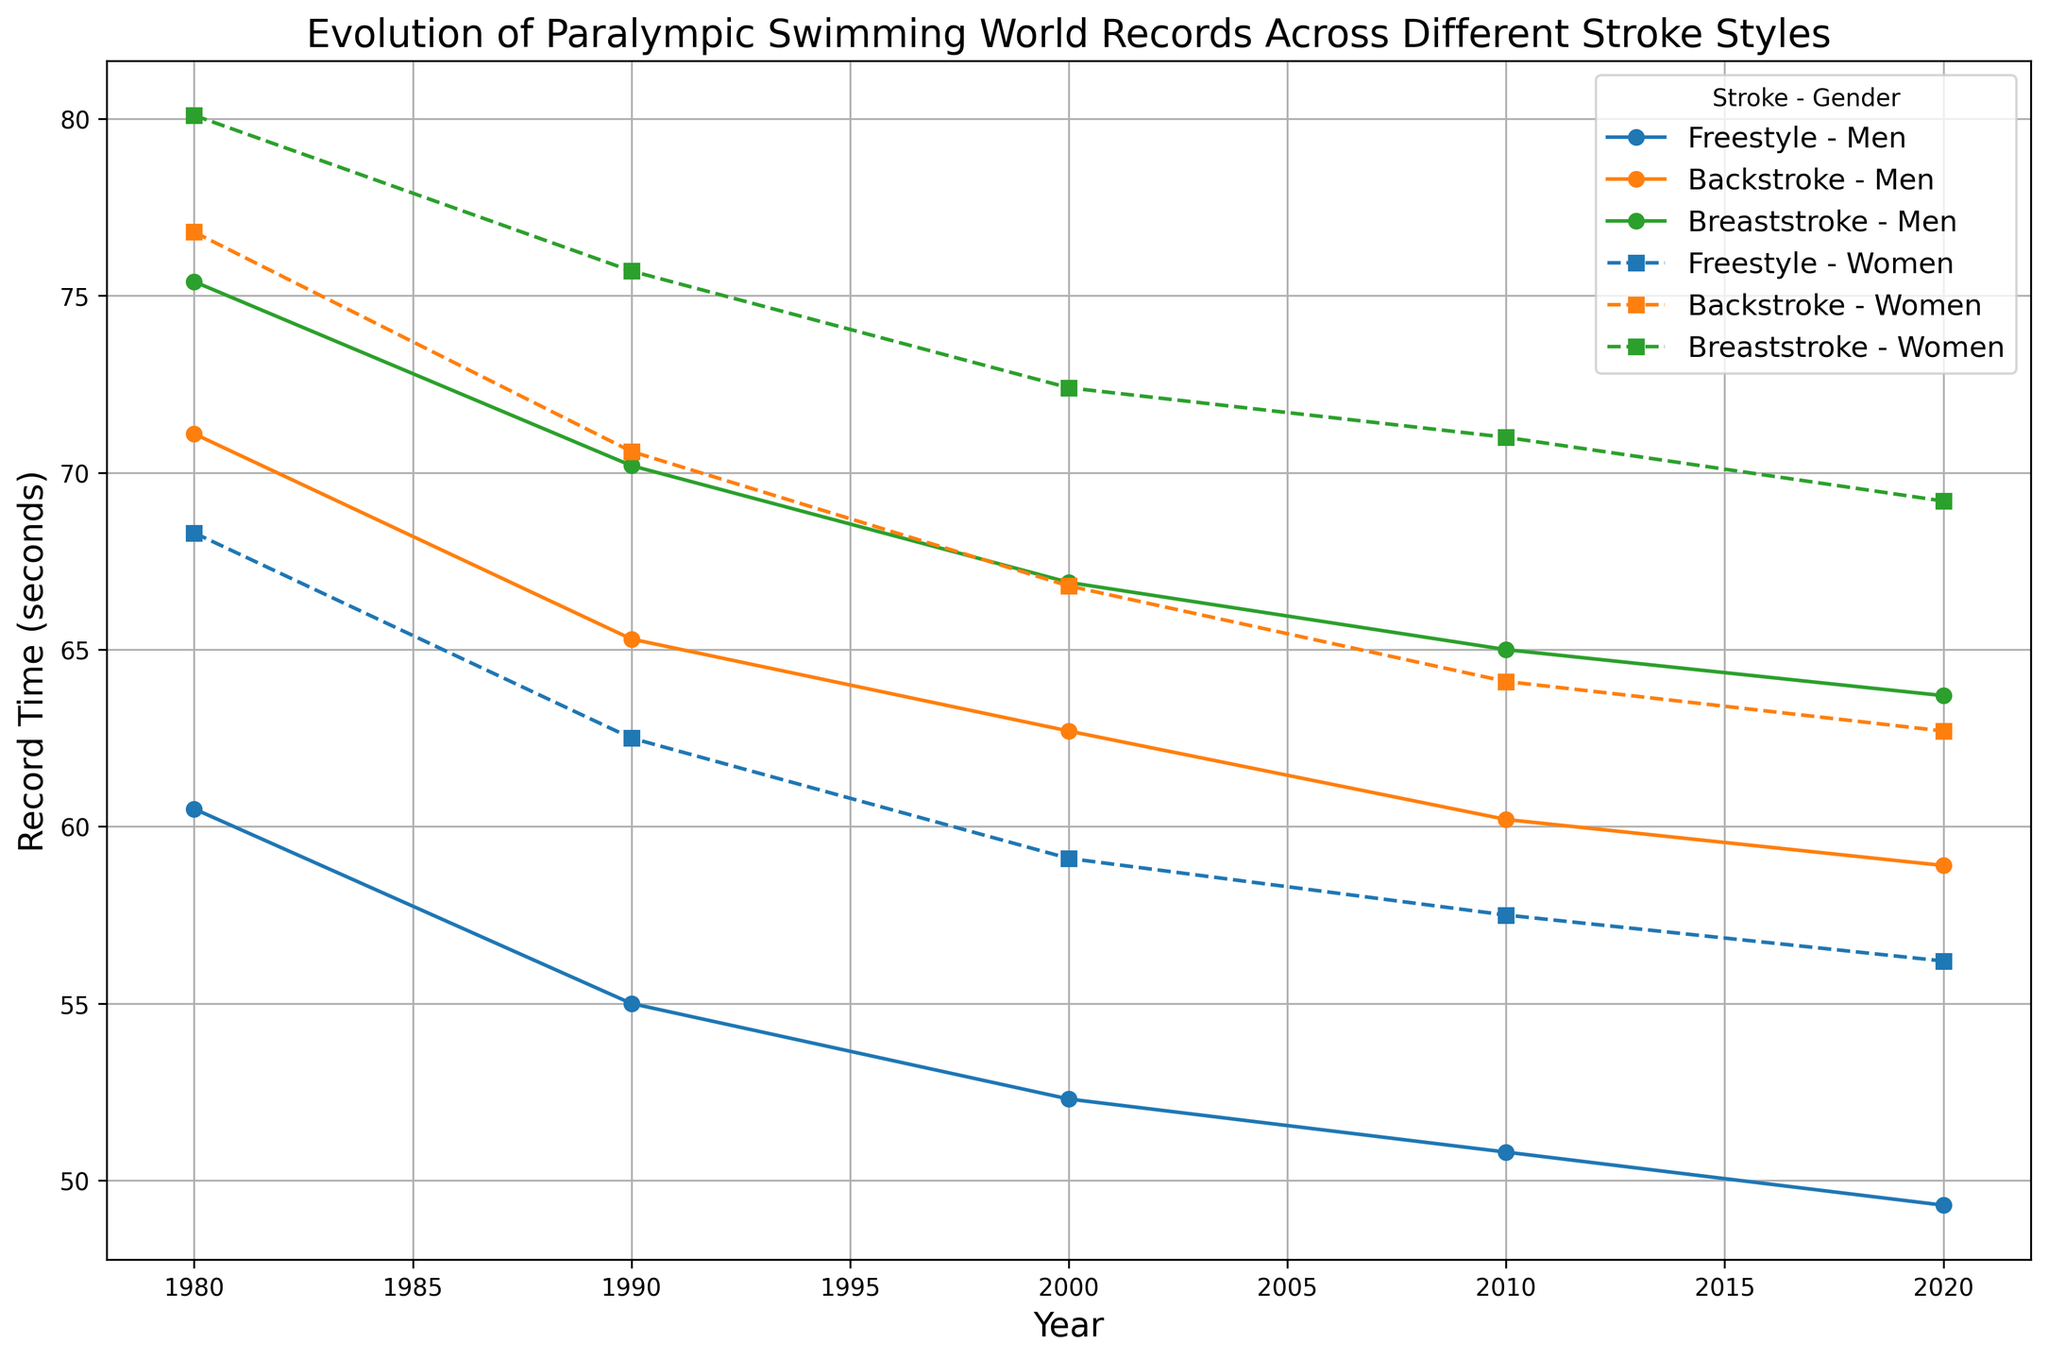Between Backstroke and Breaststroke, which stroke style had a consistent improvement for men over the years? Examine the plots for men in Backstroke and Breaststroke from 1980 to 2020. Both strokes show consistent improvements, but Breaststroke has a more gradual and steady decrease in time.
Answer: Breaststroke What is the average record time across all strokes for women in 1990? Sum the record times for women in Freestyle, Backstroke, and Breaststroke in 1990 and divide by 3. (62.5 + 70.6 + 75.7) / 3 = 69.6
Answer: 69.6 Which stroke style has the greatest difference in record times between men and women in 2010? Subtract the women's record time from the men's record time for each stroke in 2010: Freestyle (57.5 - 50.8), Backstroke (64.1 - 60.2), Breaststroke (71.0 - 65.0). The largest difference is in Breaststroke (6 seconds).
Answer: Breaststroke What pattern do you notice in men's Breaststroke records over the years? Observe the points on the graph for Men's Breaststroke from 1980 to 2020. The record times consistently decrease, suggesting a continuous improvement in performance.
Answer: Continuous improvement Compare the change in Backstroke times for men and women from 2000 to 2010. Which gender had a larger reduction in time? Subtract the 2010 record times from the 2000 times for Backstroke. Men: 62.7 - 60.2 = 2.5 seconds; Women: 66.8 - 64.1 = 2.7 seconds.
Answer: Women What's the trend in women's Freestyle world records over the four decades shown? Look at the points corresponding to women's Freestyle record times from 1980 to 2020. The record times consistently decrease each decade indicating continuous improvement.
Answer: Continuous improvement What is the difference between men's and women's Breaststroke world records in 2020? Subtract the women's Breaststroke record time from the men's Breaststroke record time in 2020. 69.2 - 63.7 = 5.5 seconds.
Answer: 5.5 seconds 